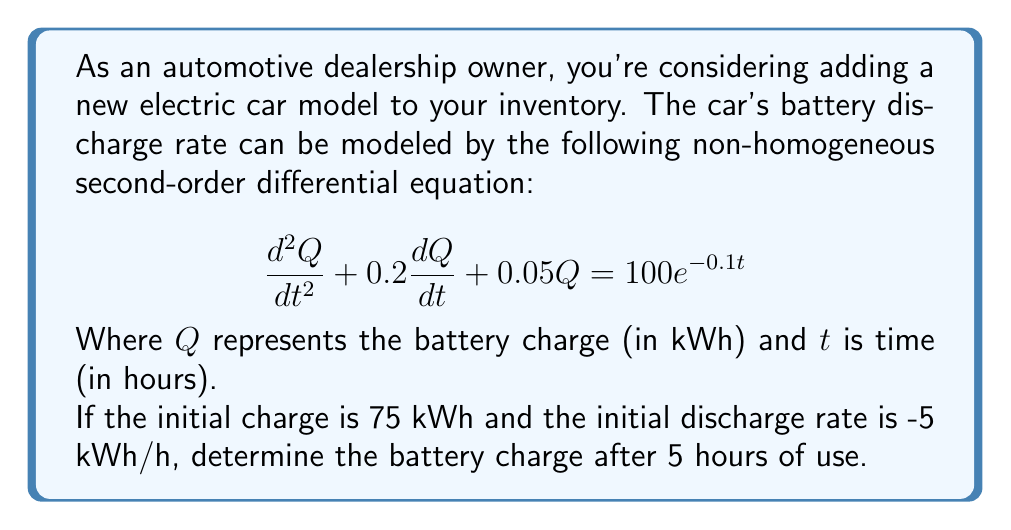Help me with this question. To solve this problem, we'll follow these steps:

1) First, we need to find the general solution to the homogeneous equation:
   $$\frac{d^2Q}{dt^2} + 0.2\frac{dQ}{dt} + 0.05Q = 0$$

   The characteristic equation is: $r^2 + 0.2r + 0.05 = 0$
   Solving this, we get: $r = -0.1 \pm 0.1i$

   So the homogeneous solution is:
   $$Q_h = e^{-0.1t}(c_1\cos(0.1t) + c_2\sin(0.1t))$$

2) For the particular solution, we guess a form:
   $$Q_p = Ae^{-0.1t}$$

   Substituting this into the original equation:
   $$0.01Ae^{-0.1t} - 0.02Ae^{-0.1t} + 0.05Ae^{-0.1t} = 100e^{-0.1t}$$
   $$0.04Ae^{-0.1t} = 100e^{-0.1t}$$
   $$A = 2500$$

   So the particular solution is:
   $$Q_p = 2500e^{-0.1t}$$

3) The general solution is the sum of homogeneous and particular solutions:
   $$Q = e^{-0.1t}(c_1\cos(0.1t) + c_2\sin(0.1t)) + 2500e^{-0.1t}$$

4) Now we use the initial conditions to find $c_1$ and $c_2$:
   At $t=0$, $Q = 75$ and $\frac{dQ}{dt} = -5$

   From $Q(0) = 75$:
   $$75 = c_1 + 2500$$
   $$c_1 = -2425$$

   From $Q'(0) = -5$:
   $$-5 = -0.1(-2425) + 0.1c_2 - 250$$
   $$c_2 = 2175$$

5) So the final solution is:
   $$Q = e^{-0.1t}(-2425\cos(0.1t) + 2175\sin(0.1t)) + 2500e^{-0.1t}$$

6) To find the charge after 5 hours, we substitute $t=5$:
   $$Q(5) = e^{-0.5}(-2425\cos(0.5) + 2175\sin(0.5)) + 2500e^{-0.5}$$
   $$\approx 70.68 \text{ kWh}$$
Answer: 70.68 kWh 